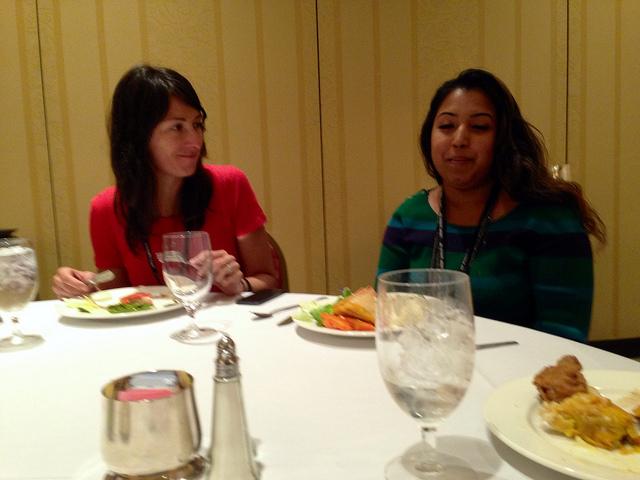Is there soup on the table?
Give a very brief answer. No. Why are they smiling?
Keep it brief. Happy. How many people are seated at the table?
Quick response, please. 2. How many wine glasses are on the table?
Be succinct. 3. What is in the glass?
Give a very brief answer. Water. What soda is there?
Answer briefly. None. What are these people doing?
Be succinct. Eating. Is the woman pleased that the picture is being taken?
Keep it brief. Yes. What is the woman eating?
Short answer required. Chicken. What are the women doing?
Give a very brief answer. Eating. What design is on the curtains?
Concise answer only. Stripes. How many women are pictured?
Answer briefly. 2. What is the lady holding in her hand?
Quick response, please. Fork. Are both girls drinking?
Short answer required. No. Is there a butter plate on the table?
Be succinct. No. What kind of wine is in the glasses?
Answer briefly. Water. How many people are in the picture?
Answer briefly. 2. Is this on a patio?
Write a very short answer. No. 